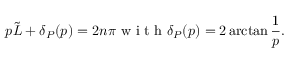Convert formula to latex. <formula><loc_0><loc_0><loc_500><loc_500>p \tilde { L } + \delta _ { P } ( p ) = 2 n \pi w i t h \delta _ { P } ( p ) = 2 \arctan \frac { 1 } { p } .</formula> 